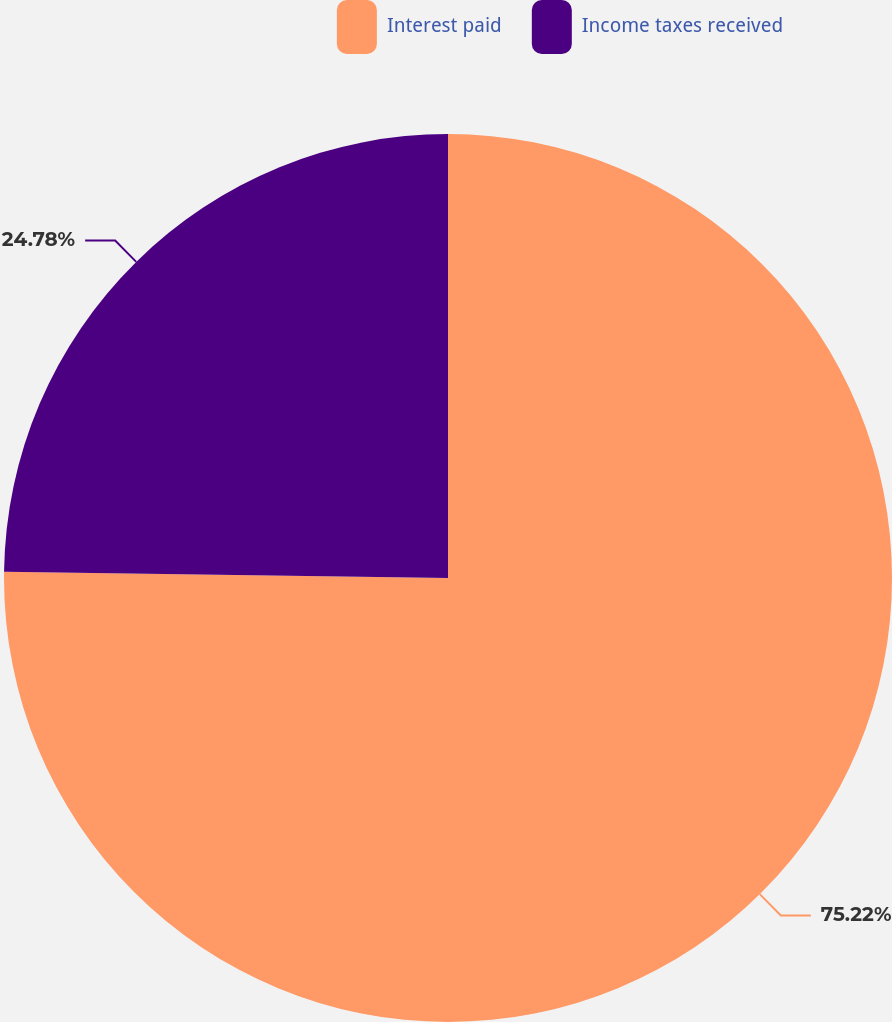Convert chart. <chart><loc_0><loc_0><loc_500><loc_500><pie_chart><fcel>Interest paid<fcel>Income taxes received<nl><fcel>75.22%<fcel>24.78%<nl></chart> 